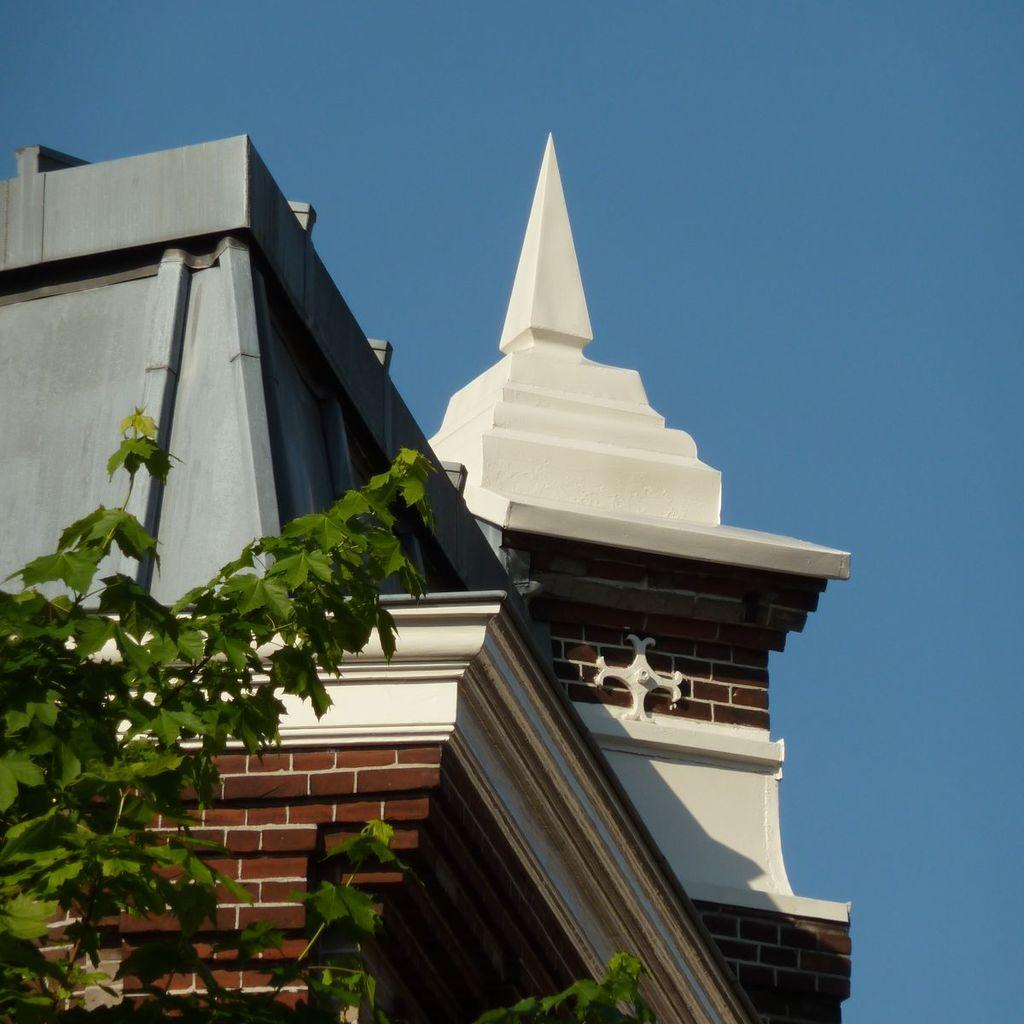What type of structure is present in the image? There is a building in the image. What type of vegetation is present in the image? There is a tree in the image. What can be seen in the background of the image? The sky is visible in the background of the image. How many girls are sitting in the nest at the top of the tree in the image? There is no nest or girls present in the image; it features a building and a tree. 